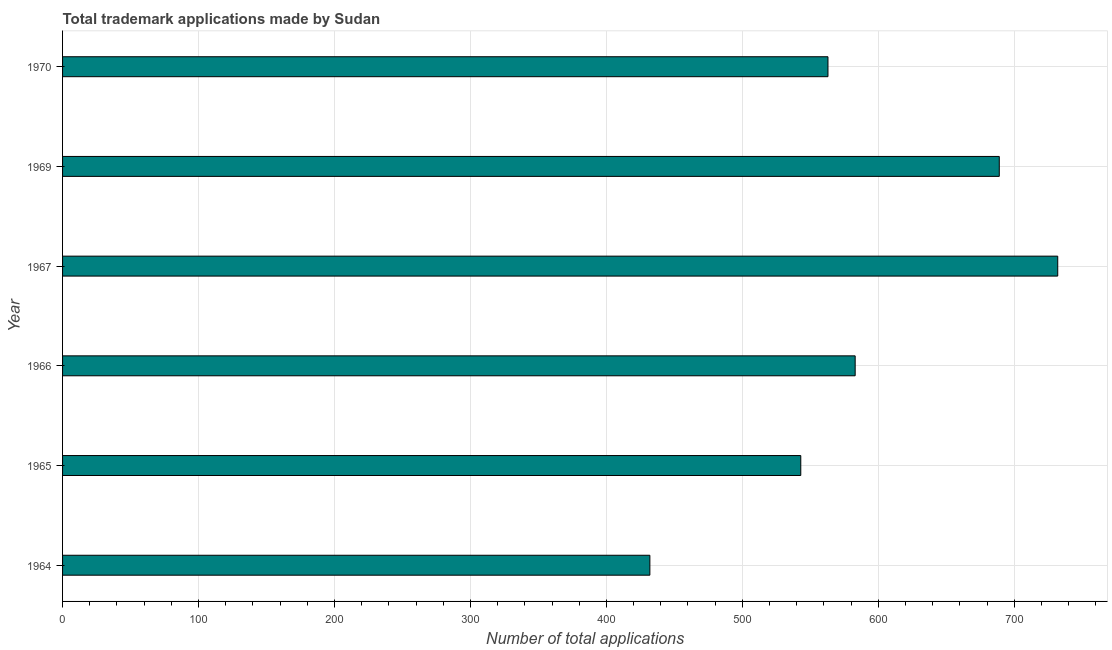Does the graph contain any zero values?
Offer a terse response. No. Does the graph contain grids?
Keep it short and to the point. Yes. What is the title of the graph?
Provide a succinct answer. Total trademark applications made by Sudan. What is the label or title of the X-axis?
Give a very brief answer. Number of total applications. What is the number of trademark applications in 1965?
Give a very brief answer. 543. Across all years, what is the maximum number of trademark applications?
Your answer should be very brief. 732. Across all years, what is the minimum number of trademark applications?
Your answer should be compact. 432. In which year was the number of trademark applications maximum?
Give a very brief answer. 1967. In which year was the number of trademark applications minimum?
Provide a short and direct response. 1964. What is the sum of the number of trademark applications?
Offer a very short reply. 3542. What is the difference between the number of trademark applications in 1966 and 1969?
Keep it short and to the point. -106. What is the average number of trademark applications per year?
Make the answer very short. 590. What is the median number of trademark applications?
Your answer should be very brief. 573. In how many years, is the number of trademark applications greater than 280 ?
Keep it short and to the point. 6. What is the ratio of the number of trademark applications in 1969 to that in 1970?
Give a very brief answer. 1.22. Is the difference between the number of trademark applications in 1965 and 1967 greater than the difference between any two years?
Provide a succinct answer. No. What is the difference between the highest and the second highest number of trademark applications?
Keep it short and to the point. 43. Is the sum of the number of trademark applications in 1964 and 1965 greater than the maximum number of trademark applications across all years?
Ensure brevity in your answer.  Yes. What is the difference between the highest and the lowest number of trademark applications?
Provide a short and direct response. 300. In how many years, is the number of trademark applications greater than the average number of trademark applications taken over all years?
Keep it short and to the point. 2. What is the Number of total applications of 1964?
Your response must be concise. 432. What is the Number of total applications in 1965?
Your answer should be compact. 543. What is the Number of total applications of 1966?
Give a very brief answer. 583. What is the Number of total applications of 1967?
Your response must be concise. 732. What is the Number of total applications in 1969?
Provide a succinct answer. 689. What is the Number of total applications in 1970?
Your answer should be compact. 563. What is the difference between the Number of total applications in 1964 and 1965?
Your answer should be compact. -111. What is the difference between the Number of total applications in 1964 and 1966?
Make the answer very short. -151. What is the difference between the Number of total applications in 1964 and 1967?
Offer a very short reply. -300. What is the difference between the Number of total applications in 1964 and 1969?
Your answer should be compact. -257. What is the difference between the Number of total applications in 1964 and 1970?
Give a very brief answer. -131. What is the difference between the Number of total applications in 1965 and 1967?
Your answer should be compact. -189. What is the difference between the Number of total applications in 1965 and 1969?
Provide a succinct answer. -146. What is the difference between the Number of total applications in 1966 and 1967?
Keep it short and to the point. -149. What is the difference between the Number of total applications in 1966 and 1969?
Your response must be concise. -106. What is the difference between the Number of total applications in 1967 and 1970?
Provide a short and direct response. 169. What is the difference between the Number of total applications in 1969 and 1970?
Give a very brief answer. 126. What is the ratio of the Number of total applications in 1964 to that in 1965?
Provide a succinct answer. 0.8. What is the ratio of the Number of total applications in 1964 to that in 1966?
Offer a terse response. 0.74. What is the ratio of the Number of total applications in 1964 to that in 1967?
Provide a short and direct response. 0.59. What is the ratio of the Number of total applications in 1964 to that in 1969?
Offer a very short reply. 0.63. What is the ratio of the Number of total applications in 1964 to that in 1970?
Your answer should be compact. 0.77. What is the ratio of the Number of total applications in 1965 to that in 1966?
Offer a terse response. 0.93. What is the ratio of the Number of total applications in 1965 to that in 1967?
Keep it short and to the point. 0.74. What is the ratio of the Number of total applications in 1965 to that in 1969?
Your answer should be very brief. 0.79. What is the ratio of the Number of total applications in 1966 to that in 1967?
Offer a very short reply. 0.8. What is the ratio of the Number of total applications in 1966 to that in 1969?
Offer a terse response. 0.85. What is the ratio of the Number of total applications in 1966 to that in 1970?
Your answer should be very brief. 1.04. What is the ratio of the Number of total applications in 1967 to that in 1969?
Your answer should be compact. 1.06. What is the ratio of the Number of total applications in 1969 to that in 1970?
Keep it short and to the point. 1.22. 